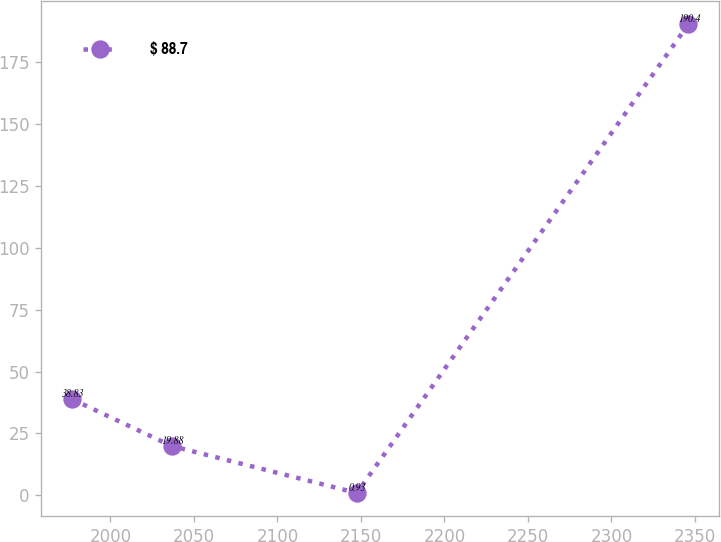<chart> <loc_0><loc_0><loc_500><loc_500><line_chart><ecel><fcel>$ 88.7<nl><fcel>1977<fcel>38.83<nl><fcel>2036.81<fcel>19.88<nl><fcel>2147.55<fcel>0.93<nl><fcel>2346.08<fcel>190.4<nl></chart> 